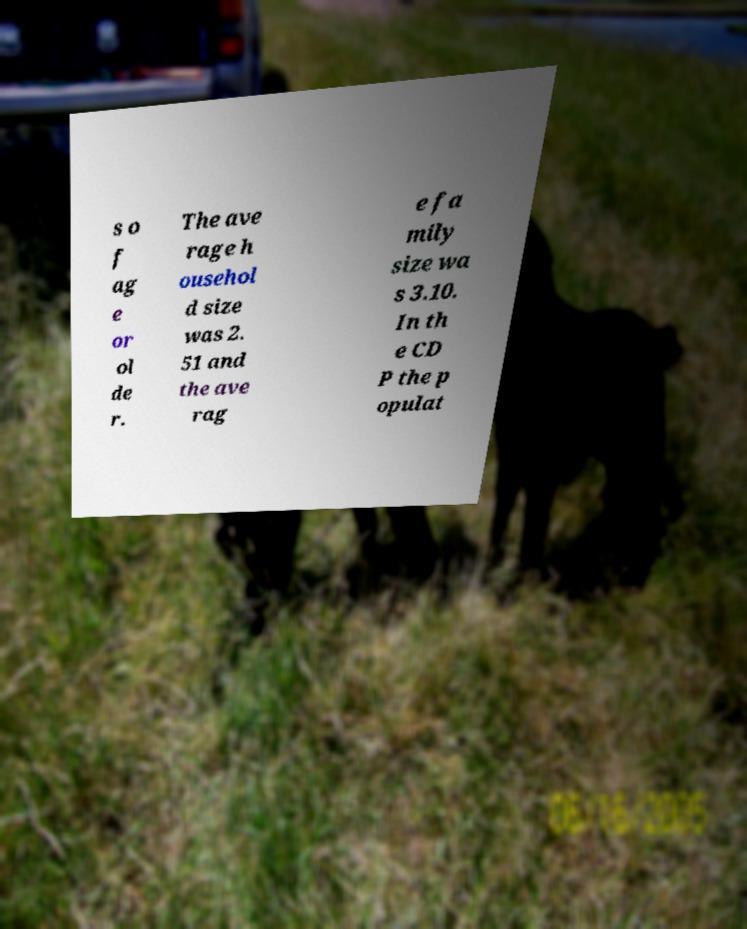Please identify and transcribe the text found in this image. s o f ag e or ol de r. The ave rage h ousehol d size was 2. 51 and the ave rag e fa mily size wa s 3.10. In th e CD P the p opulat 